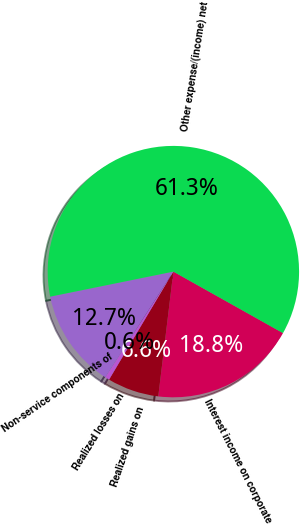<chart> <loc_0><loc_0><loc_500><loc_500><pie_chart><fcel>Interest income on corporate<fcel>Realized gains on<fcel>Realized losses on<fcel>Non-service components of<fcel>Other expense/(income) net<nl><fcel>18.78%<fcel>6.63%<fcel>0.55%<fcel>12.71%<fcel>61.32%<nl></chart> 